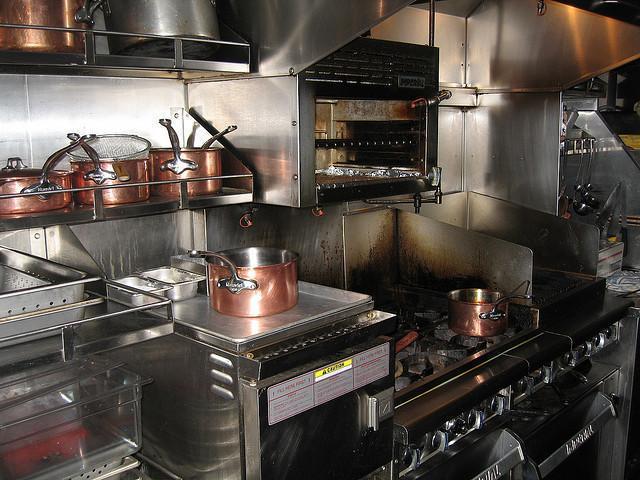How many ovens are there?
Give a very brief answer. 3. How many people are wearing a jacket in the picture?
Give a very brief answer. 0. 